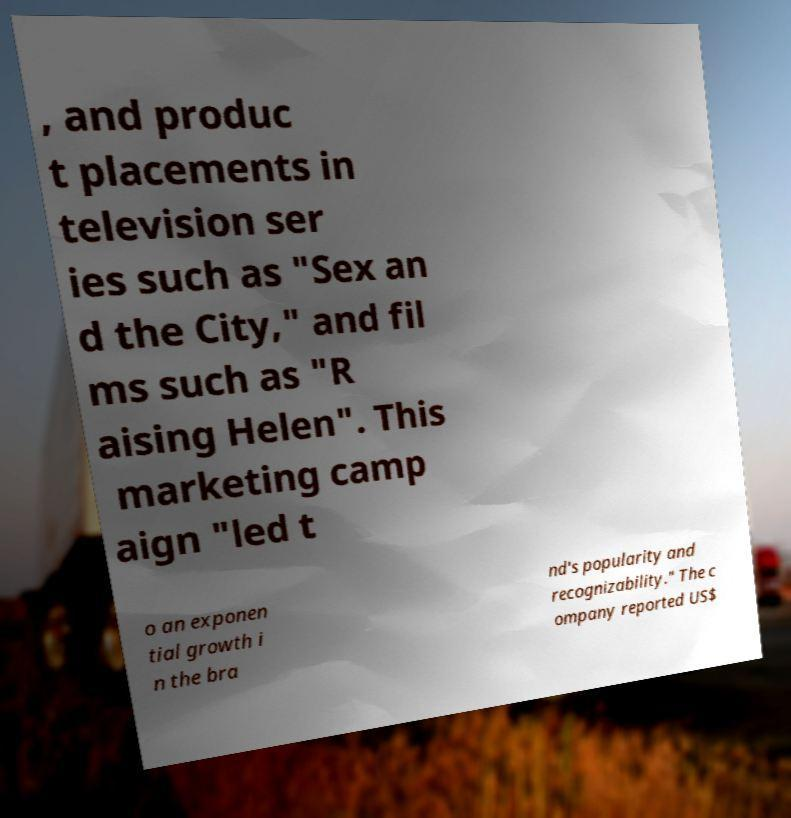For documentation purposes, I need the text within this image transcribed. Could you provide that? , and produc t placements in television ser ies such as "Sex an d the City," and fil ms such as "R aising Helen". This marketing camp aign "led t o an exponen tial growth i n the bra nd's popularity and recognizability." The c ompany reported US$ 